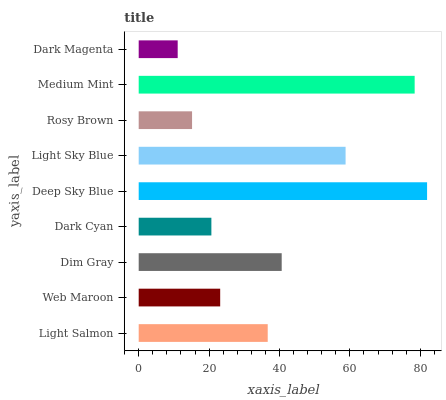Is Dark Magenta the minimum?
Answer yes or no. Yes. Is Deep Sky Blue the maximum?
Answer yes or no. Yes. Is Web Maroon the minimum?
Answer yes or no. No. Is Web Maroon the maximum?
Answer yes or no. No. Is Light Salmon greater than Web Maroon?
Answer yes or no. Yes. Is Web Maroon less than Light Salmon?
Answer yes or no. Yes. Is Web Maroon greater than Light Salmon?
Answer yes or no. No. Is Light Salmon less than Web Maroon?
Answer yes or no. No. Is Light Salmon the high median?
Answer yes or no. Yes. Is Light Salmon the low median?
Answer yes or no. Yes. Is Dim Gray the high median?
Answer yes or no. No. Is Dim Gray the low median?
Answer yes or no. No. 